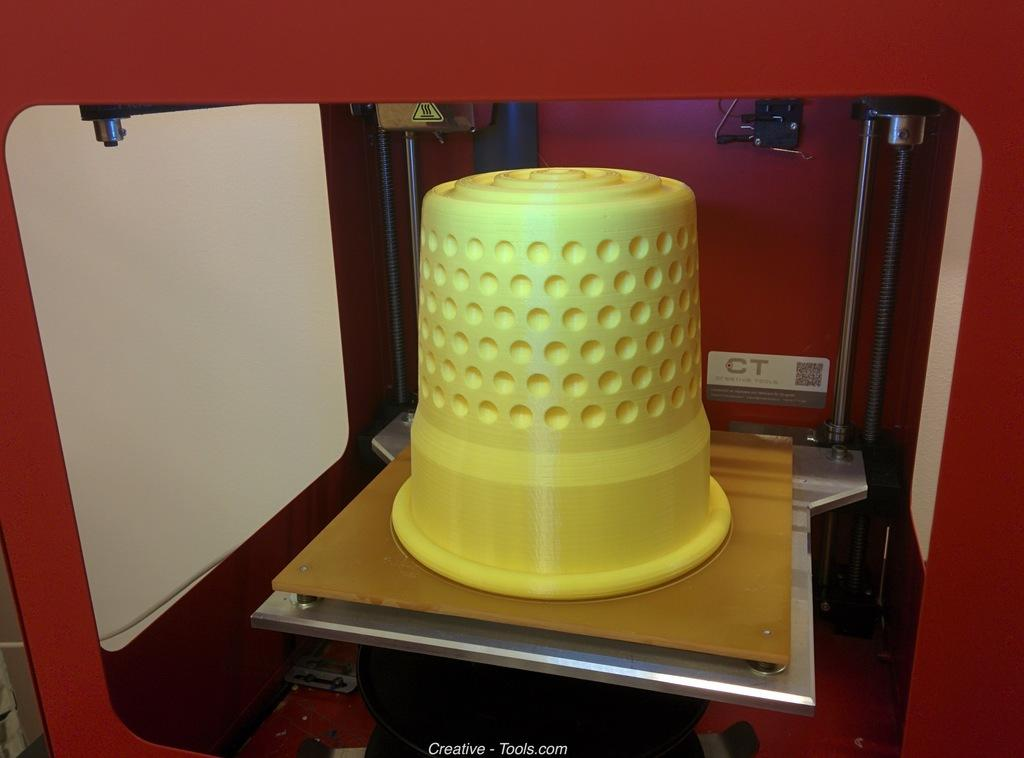What object is present in the image that can hold items? There is a basket in the image. What color is the basket? The basket is yellow in color. Where is the basket located in the image? The basket is placed in a machine. What type of machine is the basket placed in? The machine appears to be a CNC machine. What color is the CNC machine? The CNC machine is red in color. How does the umbrella contribute to the harmony of the image? There is no umbrella present in the image, so it cannot contribute to the harmony of the image. 